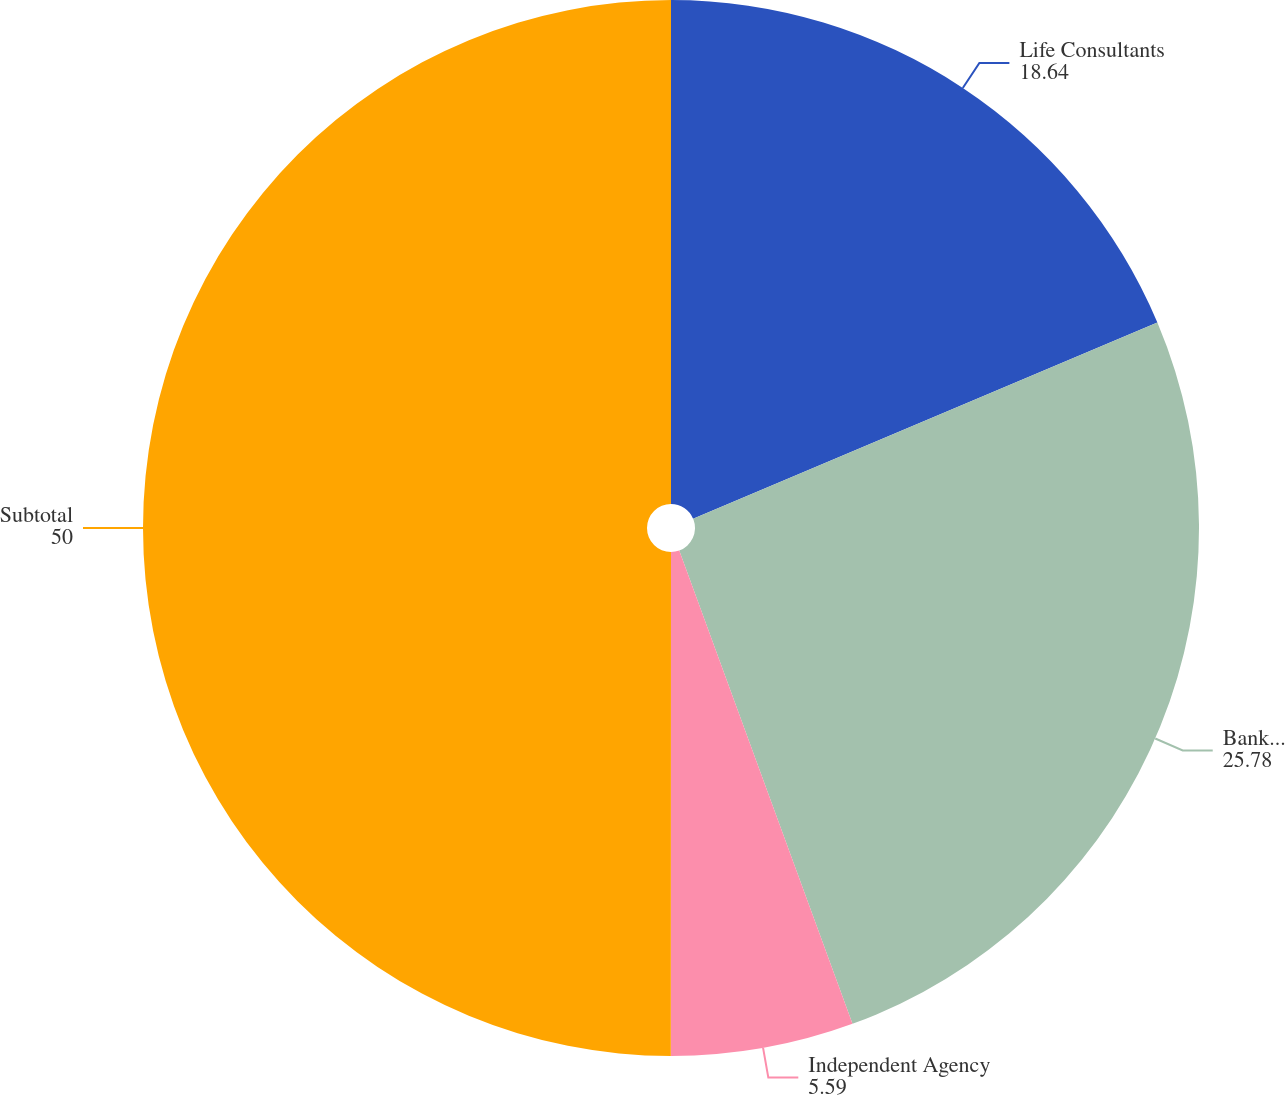Convert chart to OTSL. <chart><loc_0><loc_0><loc_500><loc_500><pie_chart><fcel>Life Consultants<fcel>Banks(2)<fcel>Independent Agency<fcel>Subtotal<nl><fcel>18.64%<fcel>25.78%<fcel>5.59%<fcel>50.0%<nl></chart> 